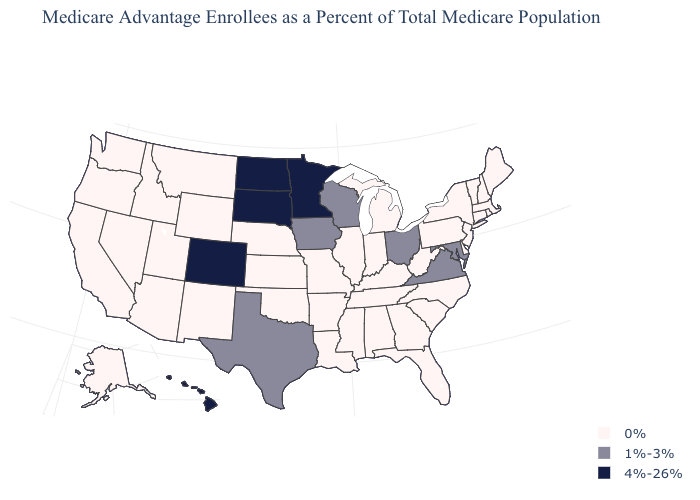Among the states that border North Dakota , does Minnesota have the lowest value?
Be succinct. No. Name the states that have a value in the range 1%-3%?
Quick response, please. Iowa, Maryland, Ohio, Texas, Virginia, Wisconsin. Which states have the lowest value in the Northeast?
Keep it brief. Connecticut, Massachusetts, Maine, New Hampshire, New Jersey, New York, Pennsylvania, Rhode Island, Vermont. Among the states that border Virginia , does Kentucky have the highest value?
Keep it brief. No. Which states have the highest value in the USA?
Write a very short answer. Colorado, Hawaii, Minnesota, North Dakota, South Dakota. What is the highest value in the MidWest ?
Short answer required. 4%-26%. What is the lowest value in the South?
Give a very brief answer. 0%. How many symbols are there in the legend?
Short answer required. 3. What is the lowest value in the South?
Keep it brief. 0%. What is the value of Alaska?
Give a very brief answer. 0%. Name the states that have a value in the range 4%-26%?
Be succinct. Colorado, Hawaii, Minnesota, North Dakota, South Dakota. What is the highest value in the Northeast ?
Give a very brief answer. 0%. What is the value of New Mexico?
Short answer required. 0%. Name the states that have a value in the range 0%?
Keep it brief. Alaska, Alabama, Arkansas, Arizona, California, Connecticut, Delaware, Florida, Georgia, Idaho, Illinois, Indiana, Kansas, Kentucky, Louisiana, Massachusetts, Maine, Michigan, Missouri, Mississippi, Montana, North Carolina, Nebraska, New Hampshire, New Jersey, New Mexico, Nevada, New York, Oklahoma, Oregon, Pennsylvania, Rhode Island, South Carolina, Tennessee, Utah, Vermont, Washington, West Virginia, Wyoming. 